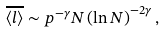<formula> <loc_0><loc_0><loc_500><loc_500>\overline { \left \langle l \right \rangle } \sim p ^ { - \gamma } N \left ( \ln N \right ) ^ { - 2 \gamma } ,</formula> 